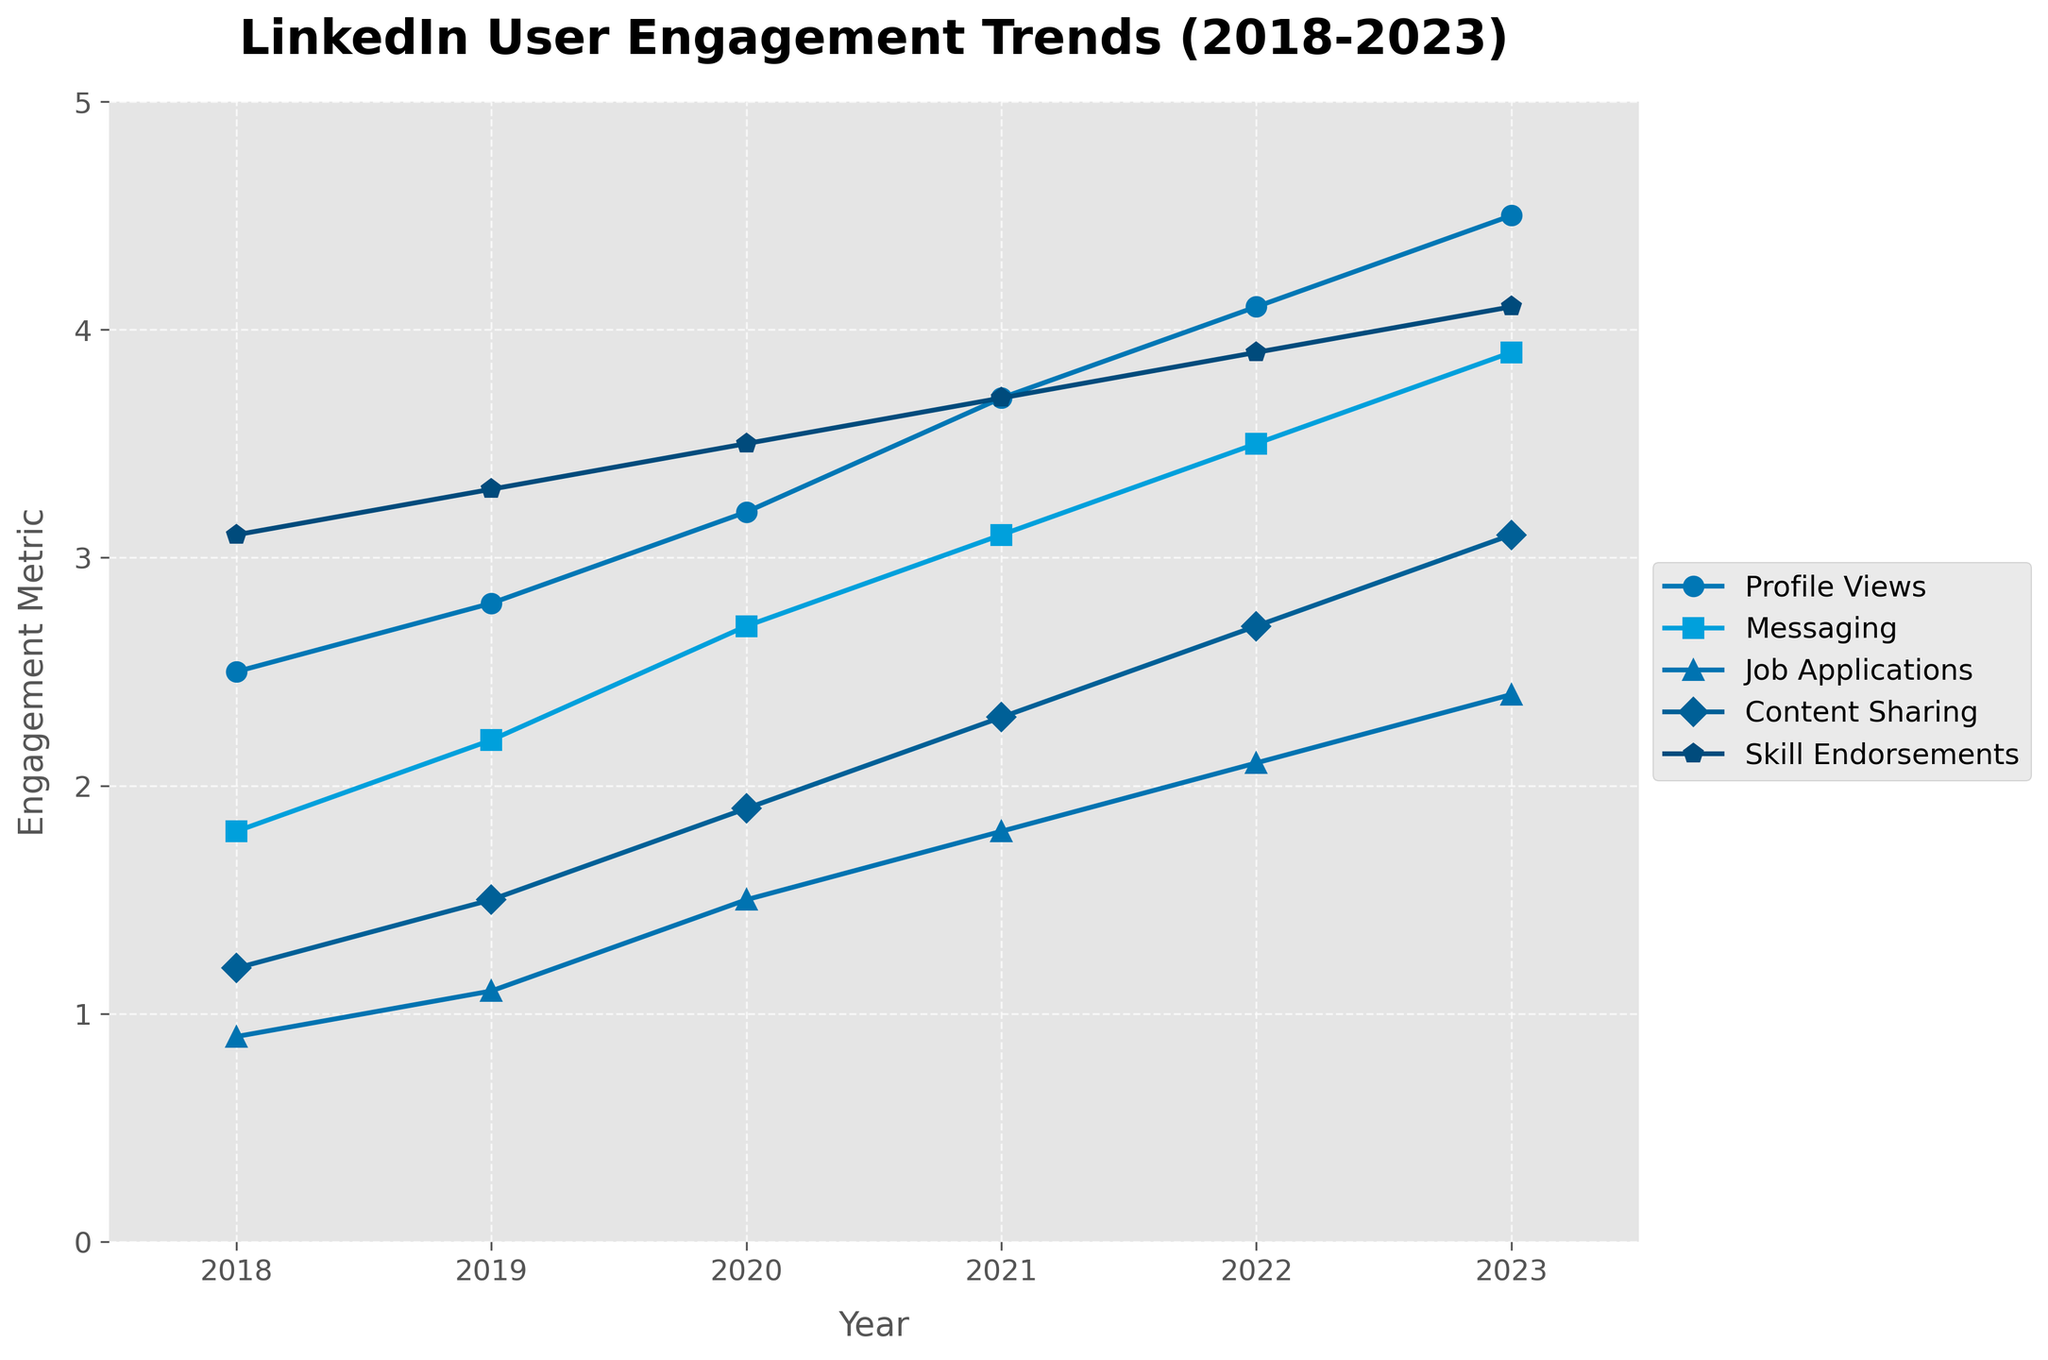Which feature has the highest engagement in 2023? In 2023, the feature with the highest engagement is the one that reaches the highest value on the y-axis. Looking at the end of each line in 2023, "Skill Endorsements" is the highest.
Answer: Skill Endorsements What is the trend of "Job Applications" from 2018 to 2023? To observe the trend, follow the line associated with "Job Applications" from 2018 to 2023. It's increasing every year.
Answer: Increasing Compare the engagement for "Profile Views" and "Messaging" in 2021. Which one is higher? In 2021, trace the lines for "Profile Views" and "Messaging" to see their heights. "Profile Views" is at 3.7 and "Messaging" is at 3.1. "Profile Views" is higher.
Answer: Profile Views Which feature had the most consistent growth over the years? A feature with consistent growth will have a smooth, steady upward line. "Profile Views" shows consistent year-over-year growth without fluctuations.
Answer: Profile Views Calculate the average engagement for "Content Sharing" from 2019 to 2023. The values for "Content Sharing" from 2019 to 2023 are 1.5, 1.9, 2.3, 2.7, and 3.1. The sum is 11.5. There are 5 years, so the average is 11.5 / 5.
Answer: 2.3 Which feature had the largest increase in engagement from 2018 to 2023? For each feature, subtract the 2018 value from the 2023 value: 
Profile Views: 4.5 - 2.5 = 2.0,
Messaging: 3.9 - 1.8 = 2.1,
Job Applications: 2.4 - 0.9 = 1.5,
Content Sharing: 3.1 - 1.2 = 1.9,
Skill Endorsements: 4.1 - 3.1 = 1.0.
"Messaging" had the largest increase.
Answer: Messaging Which year saw the biggest increase in "Content Sharing" engagement? Compare the yearly differences for "Content Sharing". From 2019 to 2020: 1.9 - 1.5 = 0.4, from 2020 to 2021: 2.3 - 1.9 = 0.4, from 2021 to 2022: 2.7 - 2.3 = 0.4, from 2022 to 2023: 3.1 - 2.7 = 0.4. Each year saw an identical increase of 0.4.
Answer: 2020, 2021, 2022, 2023 If we combine the engagements for "Messaging" and "Job Applications" in 2020, how does it compare to "Profile Views" in the same year? Add the 2020 values for "Messaging" (2.7) and "Job Applications" (1.5): 2.7 + 1.5 = 4.2. "Profile Views" in 2020 is 3.2. 4.2 is greater than 3.2.
Answer: Greater What is the difference between the highest and lowest engagement feature in 2019? In 2019, the highest engagement is for "Skill Endorsements" (3.3) and the lowest is for "Job Applications" (1.1). 
Difference: 3.3 - 1.1 = 2.2.
Answer: 2.2 